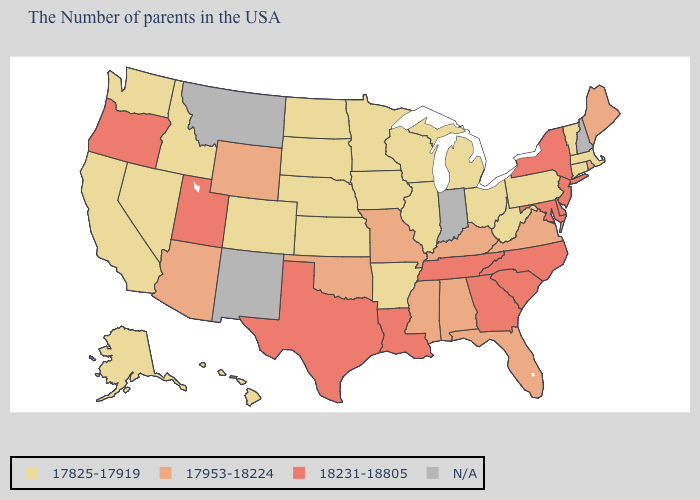What is the highest value in states that border Nebraska?
Concise answer only. 17953-18224. What is the highest value in the South ?
Answer briefly. 18231-18805. What is the value of Oregon?
Concise answer only. 18231-18805. What is the value of Maryland?
Write a very short answer. 18231-18805. What is the lowest value in the USA?
Write a very short answer. 17825-17919. What is the value of Florida?
Concise answer only. 17953-18224. Does the map have missing data?
Quick response, please. Yes. What is the value of Florida?
Keep it brief. 17953-18224. How many symbols are there in the legend?
Answer briefly. 4. Which states hav the highest value in the MidWest?
Quick response, please. Missouri. Among the states that border Montana , which have the highest value?
Keep it brief. Wyoming. What is the highest value in the USA?
Be succinct. 18231-18805. Does Louisiana have the highest value in the USA?
Short answer required. Yes. Does Missouri have the lowest value in the MidWest?
Short answer required. No. 